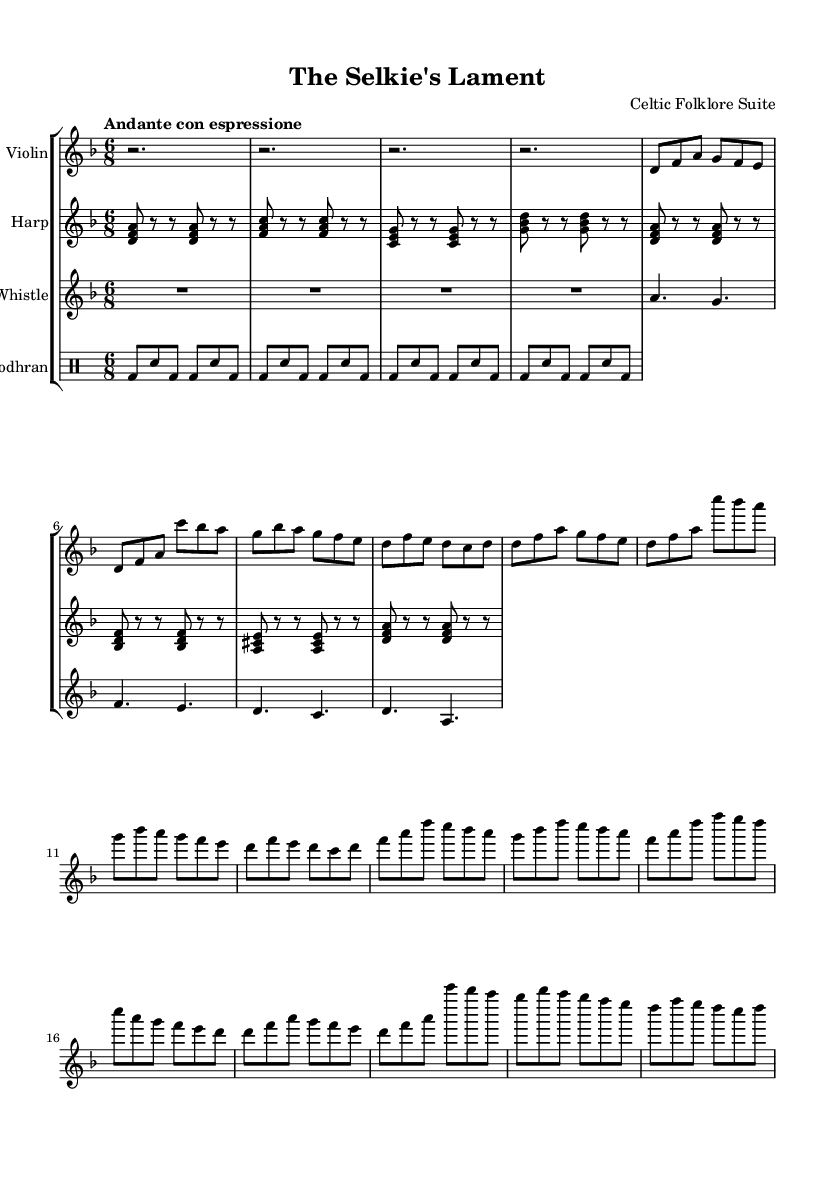What is the key signature of this music? The key signature is determined by looking at the beginning of the staff where sharp or flat symbols appear. In this score, we see two flat symbols (B and E), indicating that the piece is in D minor.
Answer: D minor What is the time signature of this music? The time signature is found at the beginning of the piece, right after the key signature. It shows how the beats are grouped in each measure. Here, the time signature is 6/8, indicating six eighth notes per measure.
Answer: 6/8 What is the tempo marking of this music? The tempo marking is usually found at the start of the piece and indicates how fast the music should be played. In the score, it says "Andante con espressione," which signifies a moderately slow tempo with expression.
Answer: Andante con espressione How many measures does the violin part have? To find the number of measures in the violin part, we count the vertical lines that indicate the end of each measure in the staff. Upon counting, the violin part consists of 12 measures.
Answer: 12 What instruments are included in this composition? The instruments are listed at the start of each staff in the score. In this piece, we see "Violin," "Harp," "Tin Whistle," and "Bodhran" specified, indicating the instruments used.
Answer: Violin, Harp, Tin Whistle, Bodhran What is the structure of the piece based on the repeated sections? By analyzing the violin part, we can observe that certain phrases are repeated. The structure includes an initial theme followed by variations, particularly in the first and second sections of the music, with many measures repeating.
Answer: AAB What is the rhythmic pattern of the bodhran part? The bodhran part rhythm can be analyzed by looking at its notation in the drum staff. It reveals a pattern of alternating bass and snare strikes, typical in traditional Celtic music, emphasizing the 6/8 meter.
Answer: Alternating bass and snare 